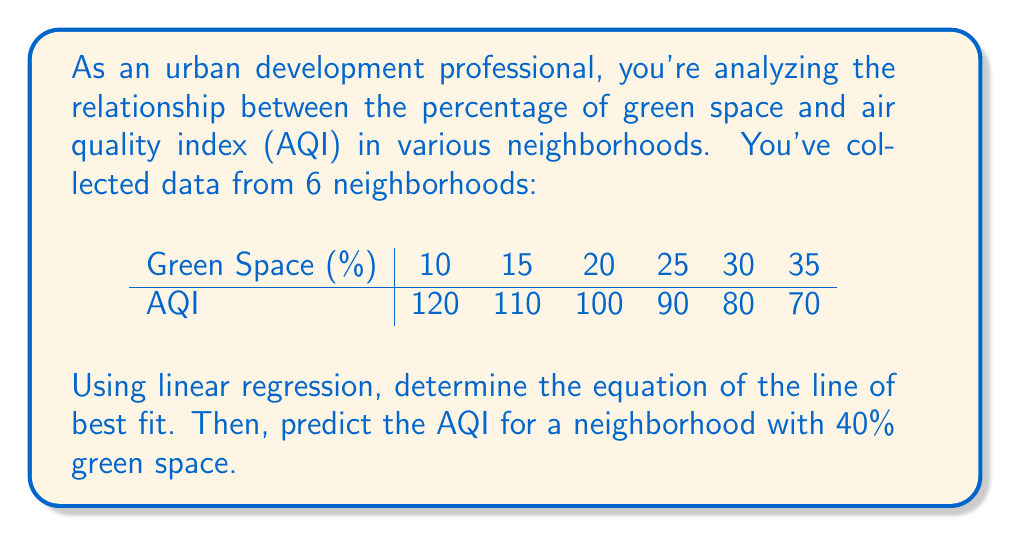Teach me how to tackle this problem. To find the line of best fit using linear regression, we'll use the equation $y = mx + b$, where $m$ is the slope and $b$ is the y-intercept.

Step 1: Calculate the means of x (green space) and y (AQI):
$\bar{x} = \frac{10 + 15 + 20 + 25 + 30 + 35}{6} = 22.5$
$\bar{y} = \frac{120 + 110 + 100 + 90 + 80 + 70}{6} = 95$

Step 2: Calculate the slope (m) using the formula:
$m = \frac{\sum(x_i - \bar{x})(y_i - \bar{y})}{\sum(x_i - \bar{x})^2}$

$m = \frac{(-12.5 \times 25) + (-7.5 \times 15) + (-2.5 \times 5) + (2.5 \times -5) + (7.5 \times -15) + (12.5 \times -25)}{(-12.5)^2 + (-7.5)^2 + (-2.5)^2 + (2.5)^2 + (7.5)^2 + (12.5)^2}$

$m = \frac{-1250}{875} = -1.4285714$

Step 3: Calculate the y-intercept (b) using the formula:
$b = \bar{y} - m\bar{x}$
$b = 95 - (-1.4285714 \times 22.5) = 127.1428571$

Step 4: Write the equation of the line of best fit:
$y = -1.4285714x + 127.1428571$

Step 5: Predict the AQI for a neighborhood with 40% green space:
$y = -1.4285714 \times 40 + 127.1428571 = 70$
Answer: $y = -1.4285714x + 127.1428571$; AQI for 40% green space: 70 